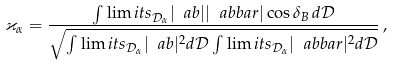<formula> <loc_0><loc_0><loc_500><loc_500>\varkappa _ { \alpha } = \frac { \int \lim i t s _ { \mathcal { D } _ { \alpha } } | \ a b | | \ a b b a r | \cos \delta _ { B } \, d \mathcal { D } } { \sqrt { \int \lim i t s _ { \mathcal { D } _ { \alpha } } | \ a b | ^ { 2 } d \mathcal { D } \int \lim i t s _ { \mathcal { D } _ { \alpha } } | \ a b b a r | ^ { 2 } d \mathcal { D } } } \, ,</formula> 